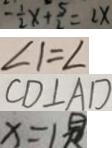<formula> <loc_0><loc_0><loc_500><loc_500>- \frac { 1 } { 2 } x + \frac { 5 } { 2 } = 2 x 
 \angle 1 = \angle 
 C D \bot A D 
 x = 1</formula> 